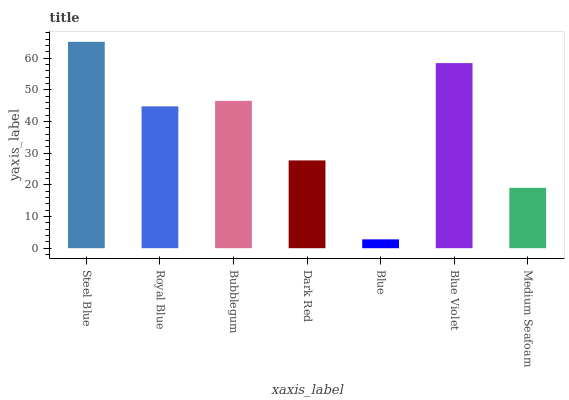Is Royal Blue the minimum?
Answer yes or no. No. Is Royal Blue the maximum?
Answer yes or no. No. Is Steel Blue greater than Royal Blue?
Answer yes or no. Yes. Is Royal Blue less than Steel Blue?
Answer yes or no. Yes. Is Royal Blue greater than Steel Blue?
Answer yes or no. No. Is Steel Blue less than Royal Blue?
Answer yes or no. No. Is Royal Blue the high median?
Answer yes or no. Yes. Is Royal Blue the low median?
Answer yes or no. Yes. Is Medium Seafoam the high median?
Answer yes or no. No. Is Blue Violet the low median?
Answer yes or no. No. 